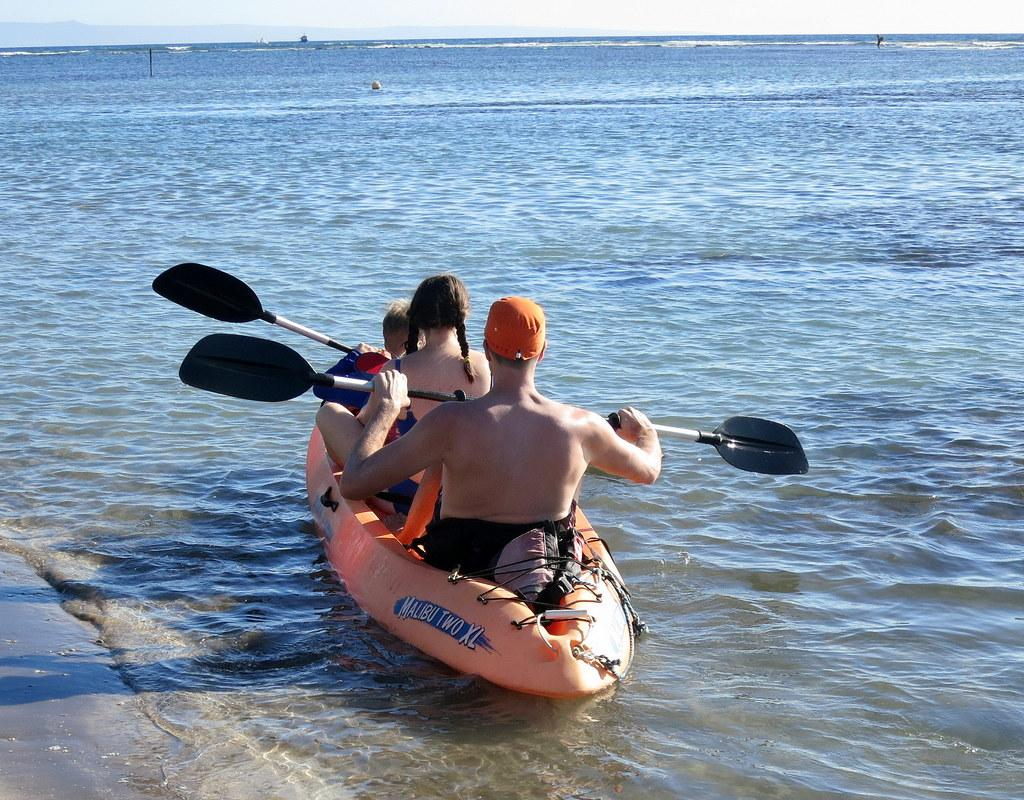What type of water body is present in the image? There is a river in the image. What is floating on the river? There is a boat in the river. How many people are in the boat? There are three persons sitting in the boat. What can be seen in the background of the image? The sky is visible in the background of the image. What type of liquid is the carpenter using to build the boat in the image? There is no carpenter present in the image, and no liquid is being used to build the boat. 